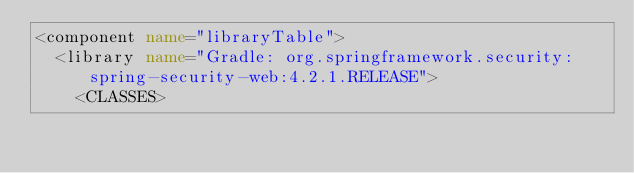<code> <loc_0><loc_0><loc_500><loc_500><_XML_><component name="libraryTable">
  <library name="Gradle: org.springframework.security:spring-security-web:4.2.1.RELEASE">
    <CLASSES></code> 